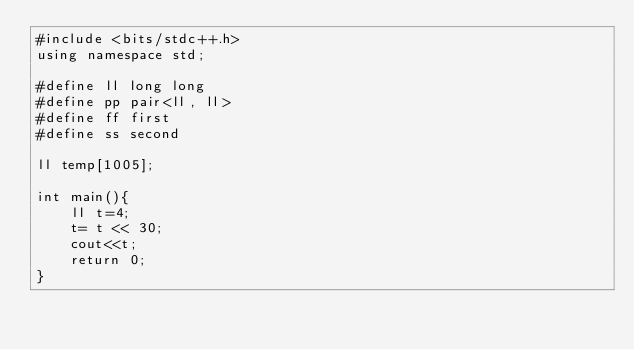<code> <loc_0><loc_0><loc_500><loc_500><_C++_>#include <bits/stdc++.h>
using namespace std;

#define ll long long
#define pp pair<ll, ll>
#define ff first 
#define ss second 

ll temp[1005];

int main(){
	ll t=4;
	t= t << 30;
	cout<<t;
	return 0;
}</code> 